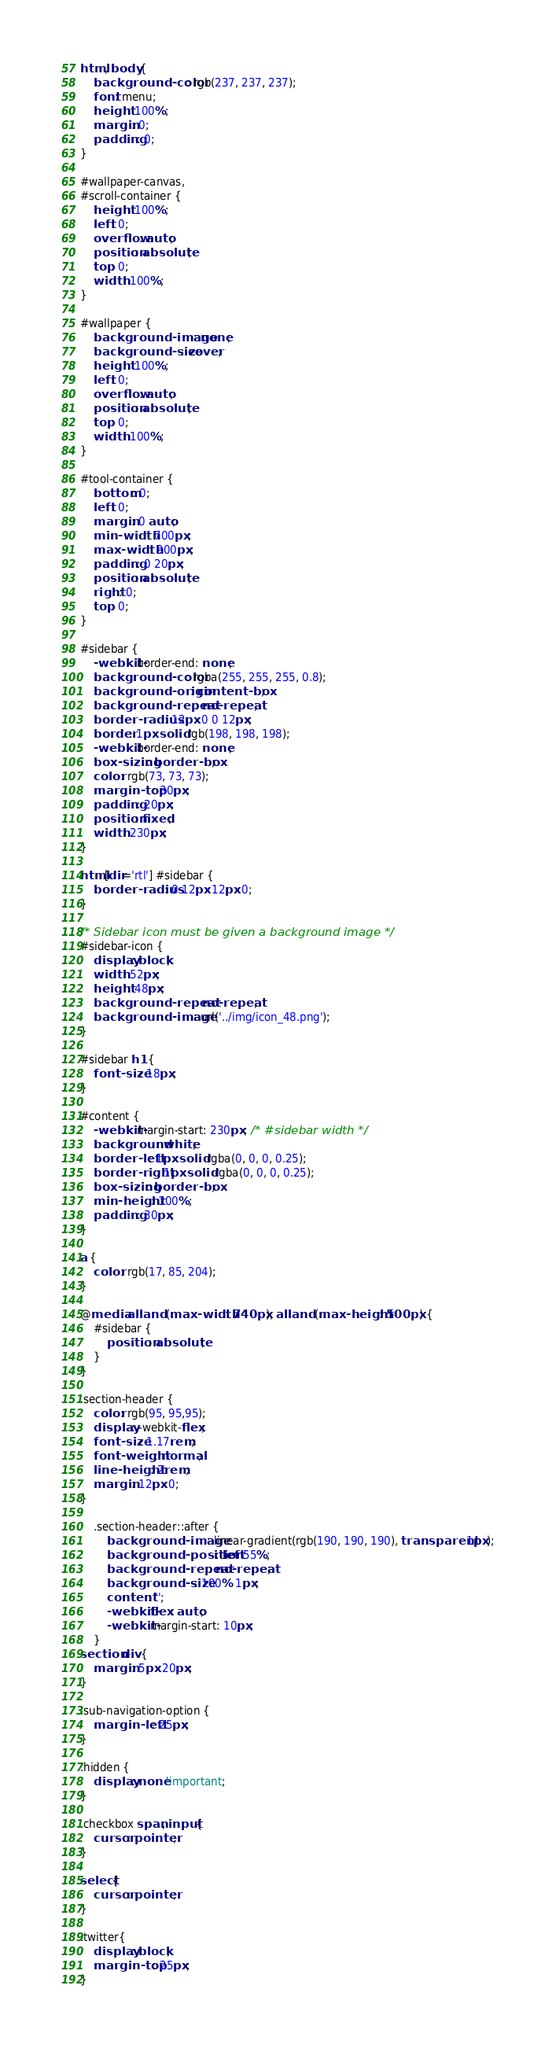Convert code to text. <code><loc_0><loc_0><loc_500><loc_500><_CSS_>html, body {
	background-color: rgb(237, 237, 237);
	font: menu;
	height: 100%;
	margin: 0;
	padding: 0;
}

#wallpaper-canvas,
#scroll-container {
	height: 100%;
	left: 0;
	overflow: auto;
	position: absolute;
	top: 0;
	width: 100%;
}

#wallpaper {
	background-image: none;
	background-size: cover;
	height: 100%;
	left: 0;
	overflow: auto;
	position: absolute;
	top: 0;
	width: 100%;
}

#tool-container {
	bottom: 0;
	left: 0;
	margin: 0 auto;
	min-width: 700px;
	max-width: 900px;
	padding: 0 20px;
	position: absolute;
	right: 0;
	top: 0;
}

#sidebar {
	-webkit-border-end: none;
	background-color: rgba(255, 255, 255, 0.8);
	background-origin: content-box;
	background-repeat: no-repeat;
	border-radius: 12px 0 0 12px;
	border: 1px solid rgb(198, 198, 198);
	-webkit-border-end: none;
	box-sizing: border-box;
	color: rgb(73, 73, 73);
	margin-top: 30px;
	padding: 20px;
	position: fixed;
	width: 230px;
}

html[dir='rtl'] #sidebar {
	border-radius: 0 12px 12px 0;
}

/* Sidebar icon must be given a background image */
#sidebar-icon {
	display: block;
	width: 52px;
	height: 48px;
	background-repeat: no-repeat;
	background-image: url('../img/icon_48.png');
}

#sidebar h1 {
	font-size: 18px;
}

#content {
	-webkit-margin-start: 230px; /* #sidebar width */
	background: white;
	border-left: 1px solid rgba(0, 0, 0, 0.25);
	border-right: 1px solid rgba(0, 0, 0, 0.25);
	box-sizing: border-box;
	min-height: 100%;
	padding: 30px;
}

a {
	color: rgb(17, 85, 204);
}

@media all and (max-width: 740px), all and (max-height: 500px) {
	#sidebar {
		position: absolute;
	}
}

.section-header {
	color: rgb(95, 95,95);
	display: -webkit-flex;
	font-size: 1.17rem;
	font-weight: normal;
	line-height: 2rem;
	margin: 12px 0;
}

	.section-header::after {
		background-image: linear-gradient(rgb(190, 190, 190), transparent 1px);
		background-position: left 55%;
		background-repeat: no-repeat;
		background-size: 100% 1px;
		content: '';
		-webkit-flex: auto;
		-webkit-margin-start: 10px;
	}
section div {
	margin: 5px 20px;
}

.sub-navigation-option {
	margin-left: 25px;
}

.hidden {
	display: none!important;
}

.checkbox span, input{
	cursor: pointer;
}

select{
	cursor: pointer;
}

.twitter{
	display: block;
	margin-top: 25px;
}</code> 